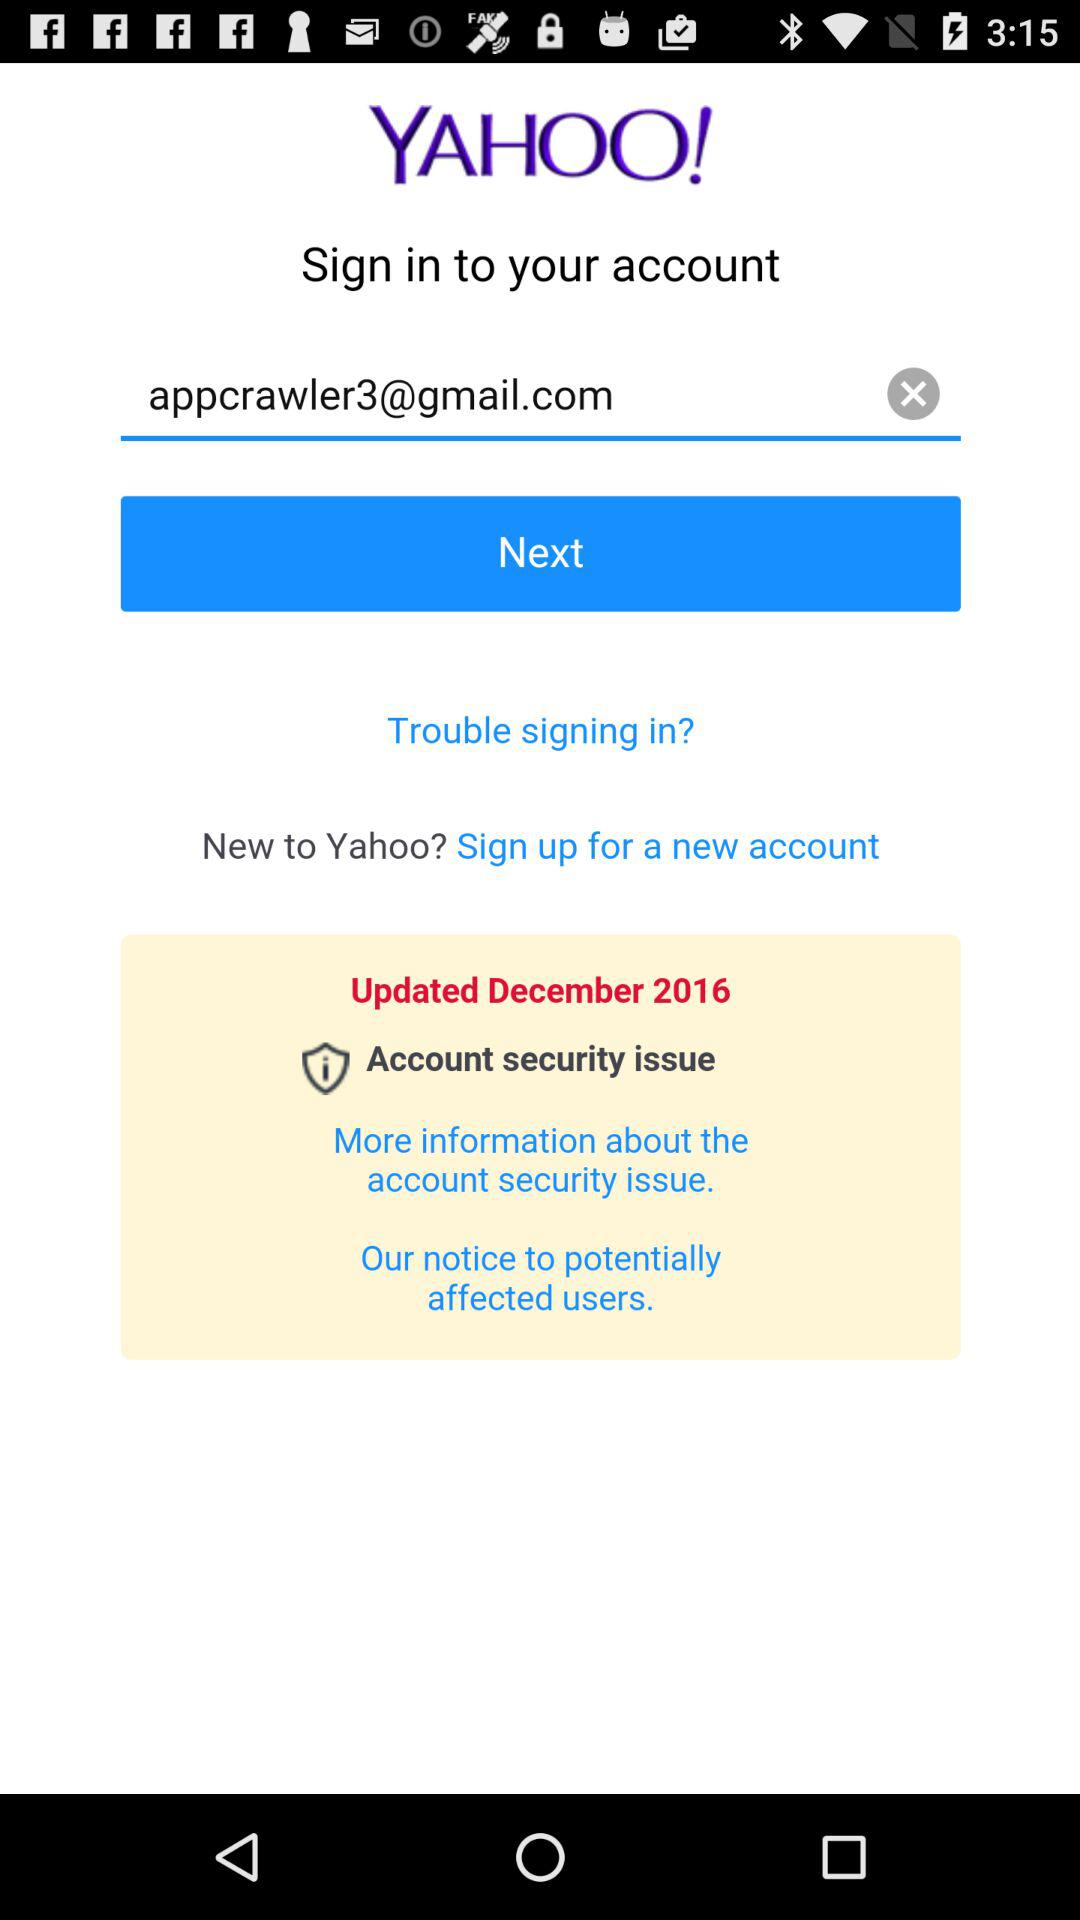When were the security issues last updated? The security issues were last updated in December 2016. 